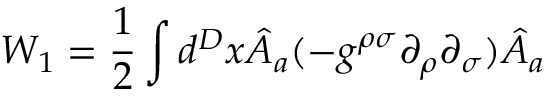<formula> <loc_0><loc_0><loc_500><loc_500>W _ { 1 } = \frac { 1 } { 2 } \int d ^ { D } x \hat { A } _ { a } ( - g ^ { \rho \sigma } \partial _ { \rho } \partial _ { \sigma } ) \hat { A } _ { a }</formula> 